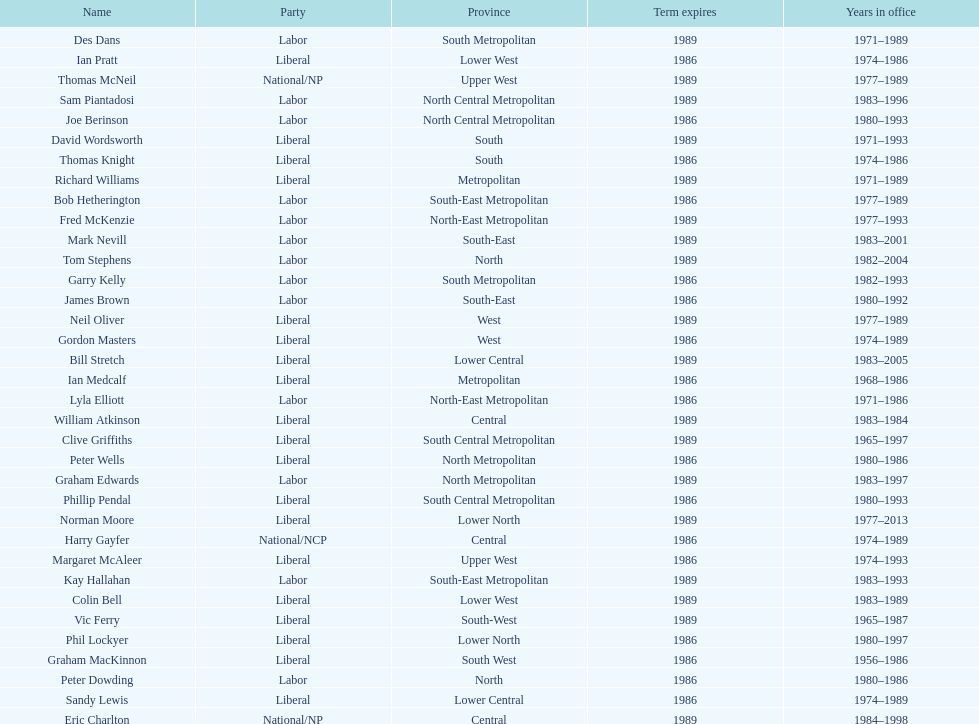I'm looking to parse the entire table for insights. Could you assist me with that? {'header': ['Name', 'Party', 'Province', 'Term expires', 'Years in office'], 'rows': [['Des Dans', 'Labor', 'South Metropolitan', '1989', '1971–1989'], ['Ian Pratt', 'Liberal', 'Lower West', '1986', '1974–1986'], ['Thomas McNeil', 'National/NP', 'Upper West', '1989', '1977–1989'], ['Sam Piantadosi', 'Labor', 'North Central Metropolitan', '1989', '1983–1996'], ['Joe Berinson', 'Labor', 'North Central Metropolitan', '1986', '1980–1993'], ['David Wordsworth', 'Liberal', 'South', '1989', '1971–1993'], ['Thomas Knight', 'Liberal', 'South', '1986', '1974–1986'], ['Richard Williams', 'Liberal', 'Metropolitan', '1989', '1971–1989'], ['Bob Hetherington', 'Labor', 'South-East Metropolitan', '1986', '1977–1989'], ['Fred McKenzie', 'Labor', 'North-East Metropolitan', '1989', '1977–1993'], ['Mark Nevill', 'Labor', 'South-East', '1989', '1983–2001'], ['Tom Stephens', 'Labor', 'North', '1989', '1982–2004'], ['Garry Kelly', 'Labor', 'South Metropolitan', '1986', '1982–1993'], ['James Brown', 'Labor', 'South-East', '1986', '1980–1992'], ['Neil Oliver', 'Liberal', 'West', '1989', '1977–1989'], ['Gordon Masters', 'Liberal', 'West', '1986', '1974–1989'], ['Bill Stretch', 'Liberal', 'Lower Central', '1989', '1983–2005'], ['Ian Medcalf', 'Liberal', 'Metropolitan', '1986', '1968–1986'], ['Lyla Elliott', 'Labor', 'North-East Metropolitan', '1986', '1971–1986'], ['William Atkinson', 'Liberal', 'Central', '1989', '1983–1984'], ['Clive Griffiths', 'Liberal', 'South Central Metropolitan', '1989', '1965–1997'], ['Peter Wells', 'Liberal', 'North Metropolitan', '1986', '1980–1986'], ['Graham Edwards', 'Labor', 'North Metropolitan', '1989', '1983–1997'], ['Phillip Pendal', 'Liberal', 'South Central Metropolitan', '1986', '1980–1993'], ['Norman Moore', 'Liberal', 'Lower North', '1989', '1977–2013'], ['Harry Gayfer', 'National/NCP', 'Central', '1986', '1974–1989'], ['Margaret McAleer', 'Liberal', 'Upper West', '1986', '1974–1993'], ['Kay Hallahan', 'Labor', 'South-East Metropolitan', '1989', '1983–1993'], ['Colin Bell', 'Liberal', 'Lower West', '1989', '1983–1989'], ['Vic Ferry', 'Liberal', 'South-West', '1989', '1965–1987'], ['Phil Lockyer', 'Liberal', 'Lower North', '1986', '1980–1997'], ['Graham MacKinnon', 'Liberal', 'South West', '1986', '1956–1986'], ['Peter Dowding', 'Labor', 'North', '1986', '1980–1986'], ['Sandy Lewis', 'Liberal', 'Lower Central', '1986', '1974–1989'], ['Eric Charlton', 'National/NP', 'Central', '1989', '1984–1998']]} Whose time in office was the shortest? William Atkinson. 